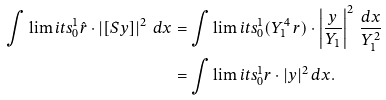Convert formula to latex. <formula><loc_0><loc_0><loc_500><loc_500>& & \int \lim i t s _ { 0 } ^ { 1 } \hat { r } \cdot \left | [ S y ] \right | ^ { 2 } \, d x & = \int \lim i t s _ { 0 } ^ { 1 } ( Y _ { 1 } ^ { 4 } \, r ) \cdot \left | \frac { y } { Y _ { 1 } } \right | ^ { 2 } \, \frac { d x } { Y _ { 1 } ^ { 2 } } & & \\ & & & = \int \lim i t s _ { 0 } ^ { 1 } r \cdot | y | ^ { 2 } \, d x .</formula> 